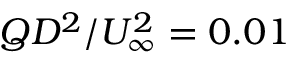<formula> <loc_0><loc_0><loc_500><loc_500>Q D ^ { 2 } / U _ { \infty } ^ { 2 } = 0 . 0 1</formula> 